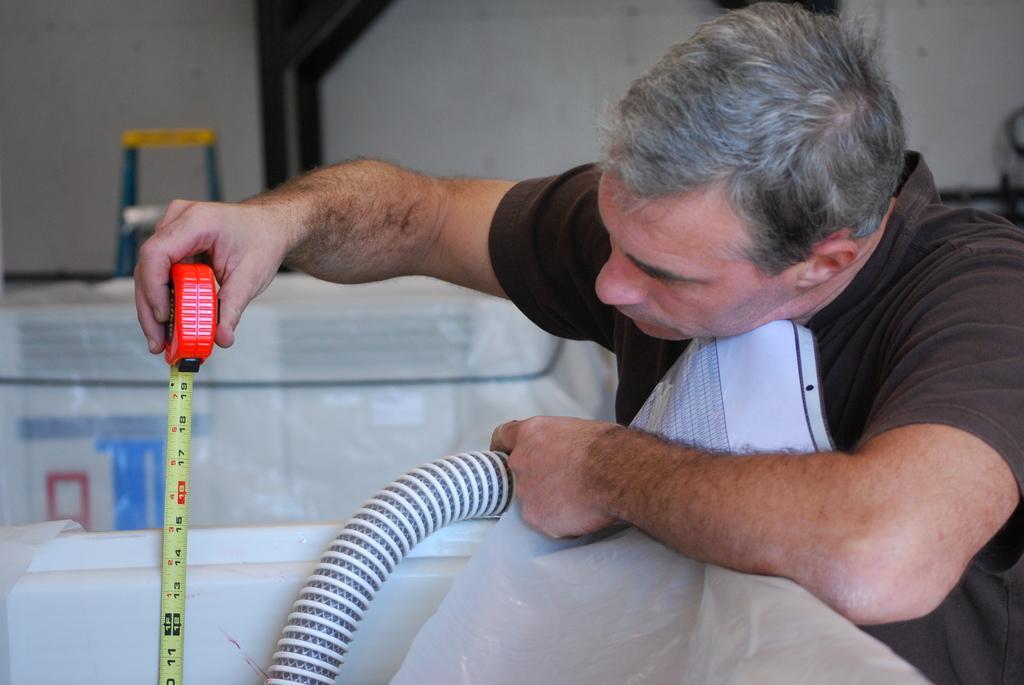Can you describe this image briefly? On the right side a man is checking the height with a tape in his hand, he wore a t-shirt. 